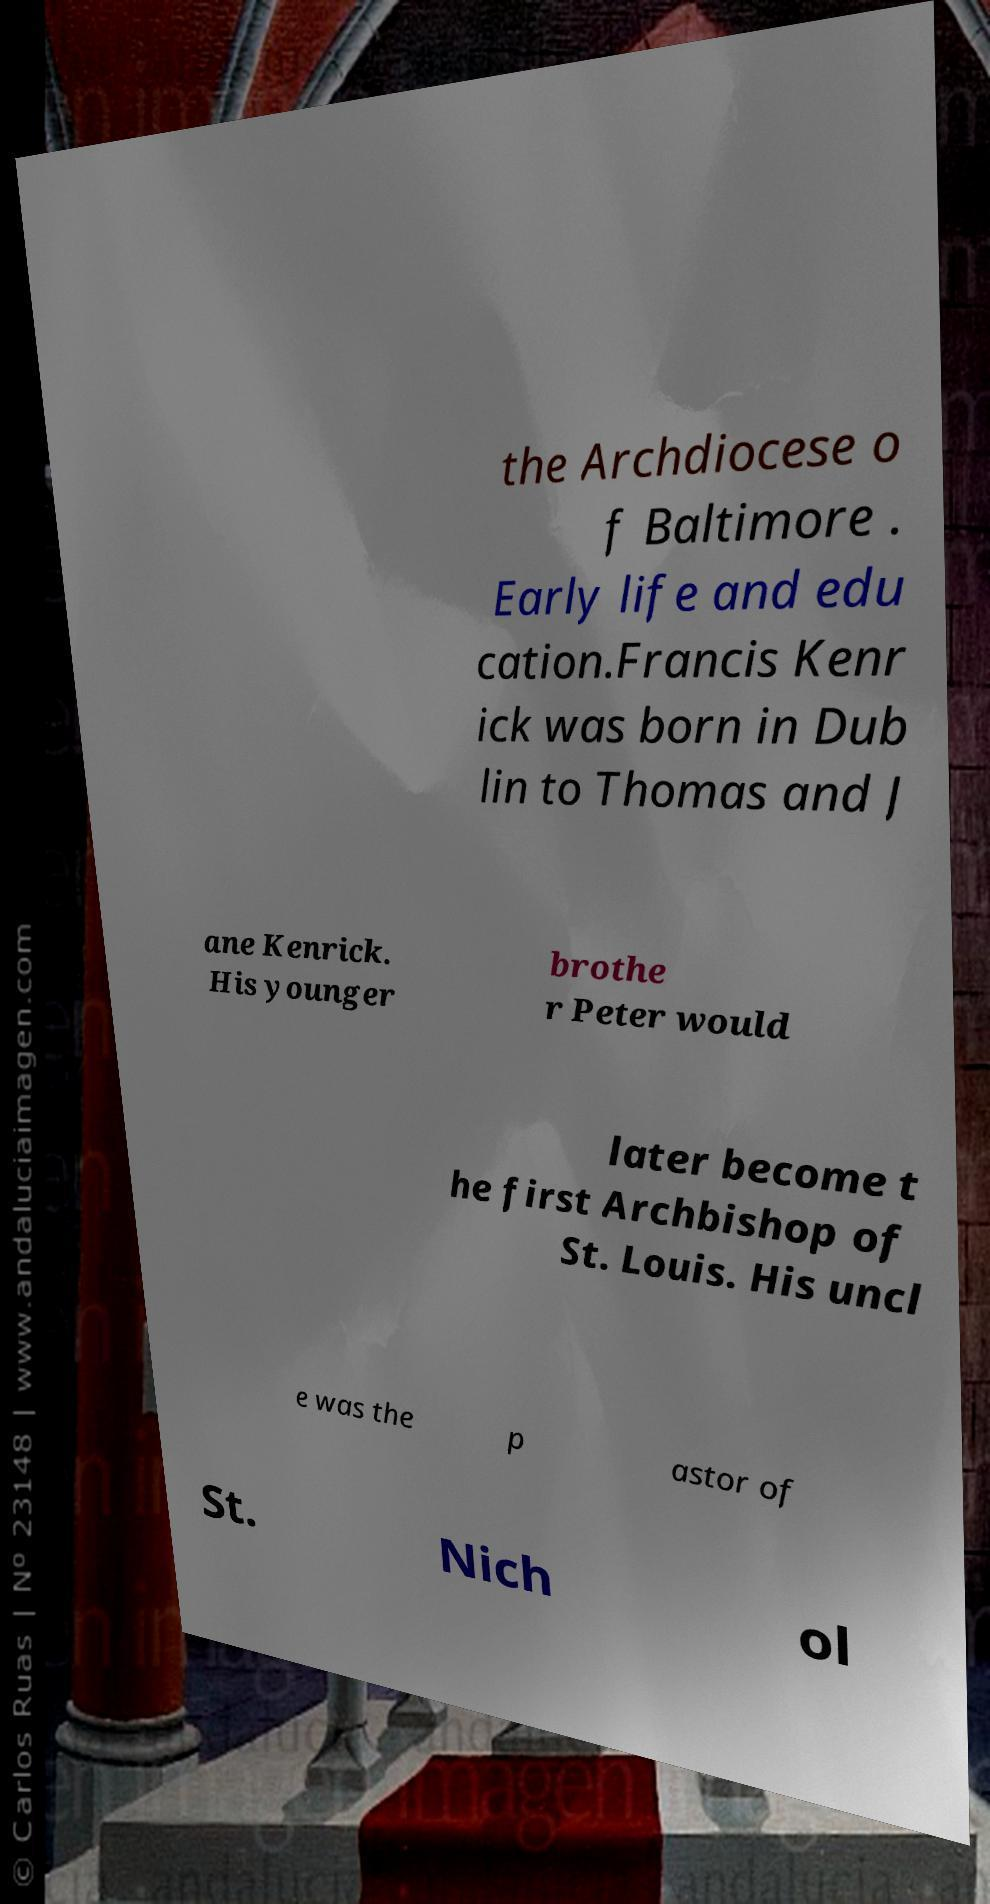Please read and relay the text visible in this image. What does it say? the Archdiocese o f Baltimore . Early life and edu cation.Francis Kenr ick was born in Dub lin to Thomas and J ane Kenrick. His younger brothe r Peter would later become t he first Archbishop of St. Louis. His uncl e was the p astor of St. Nich ol 